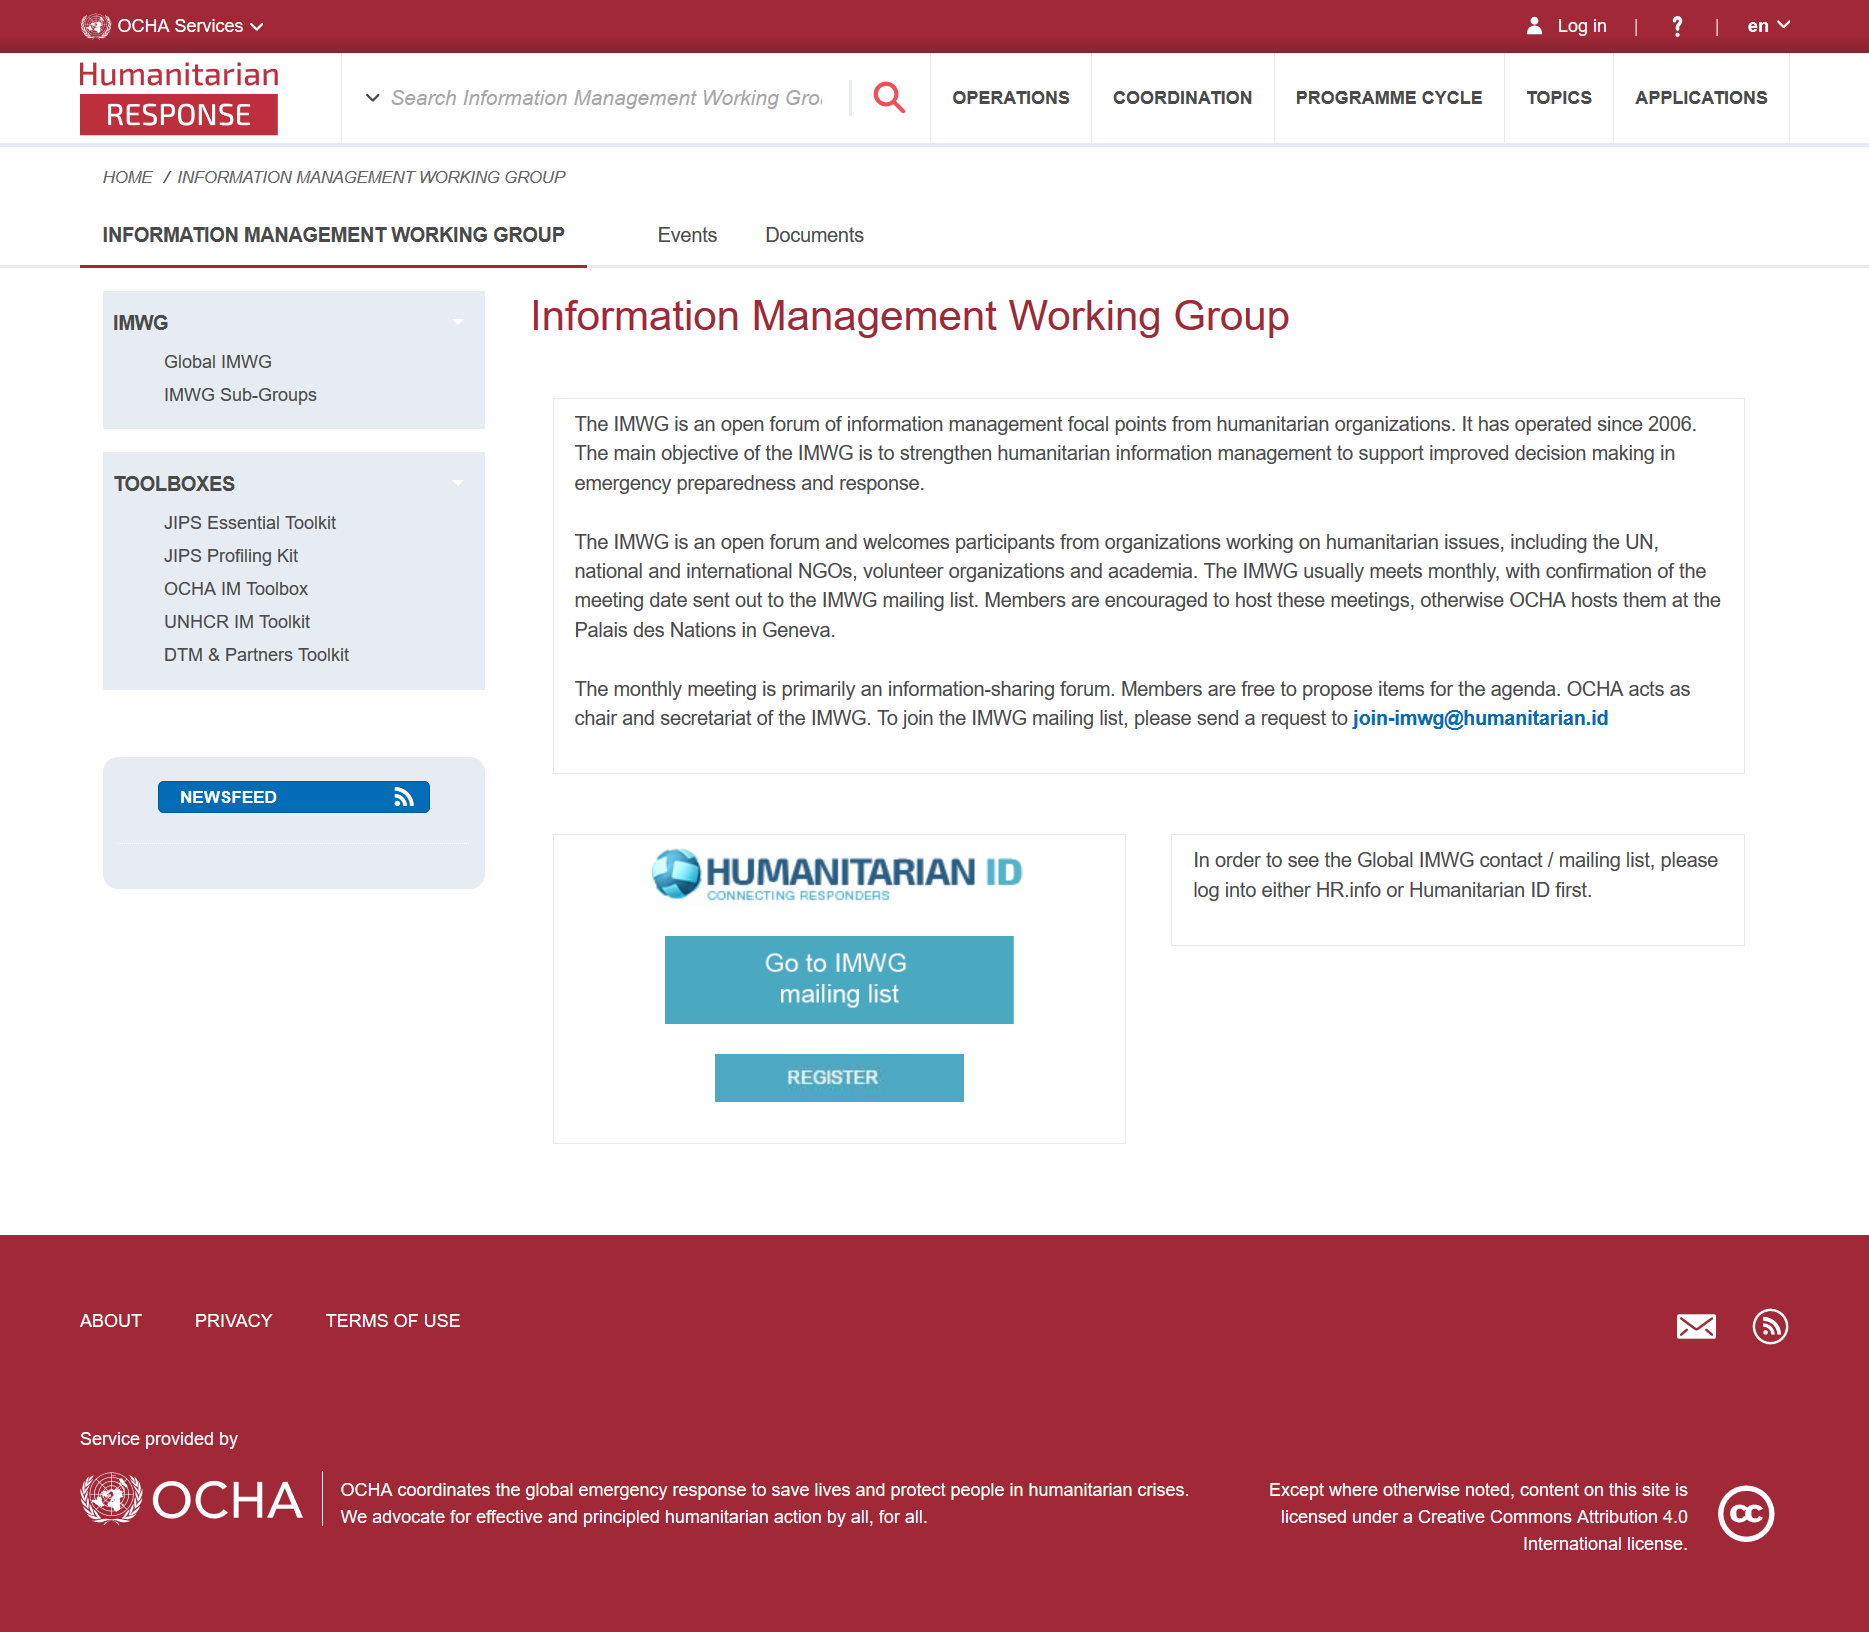Draw attention to some important aspects in this diagram. The Information Management Working Group, also known as IMWG, has been in operation since 2006. The IMWG is an open forum of information management focal points from humanitarian organizations, dedicated to providing information and resources on data management and analysis. The International Monitoring System for Comprehensive Nuclear-Test-Ban Treaty holds monthly meetings, as stated by the International Monitoring System Working Group. 